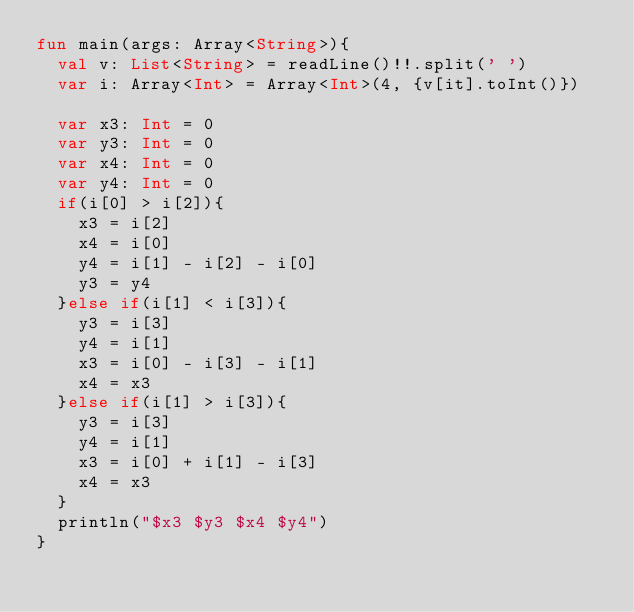Convert code to text. <code><loc_0><loc_0><loc_500><loc_500><_Kotlin_>fun main(args: Array<String>){
  val v: List<String> = readLine()!!.split(' ')
  var i: Array<Int> = Array<Int>(4, {v[it].toInt()})
  
  var x3: Int = 0
  var y3: Int = 0
  var x4: Int = 0
  var y4: Int = 0
  if(i[0] > i[2]){
	x3 = i[2]
	x4 = i[0]
	y4 = i[1] - i[2] - i[0]
	y3 = y4
  }else if(i[1] < i[3]){
	y3 = i[3]
	y4 = i[1]
	x3 = i[0] - i[3] - i[1]
	x4 = x3
  }else if(i[1] > i[3]){
	y3 = i[3]
	y4 = i[1]
	x3 = i[0] + i[1] - i[3]
	x4 = x3
  }
  println("$x3 $y3 $x4 $y4")
}</code> 